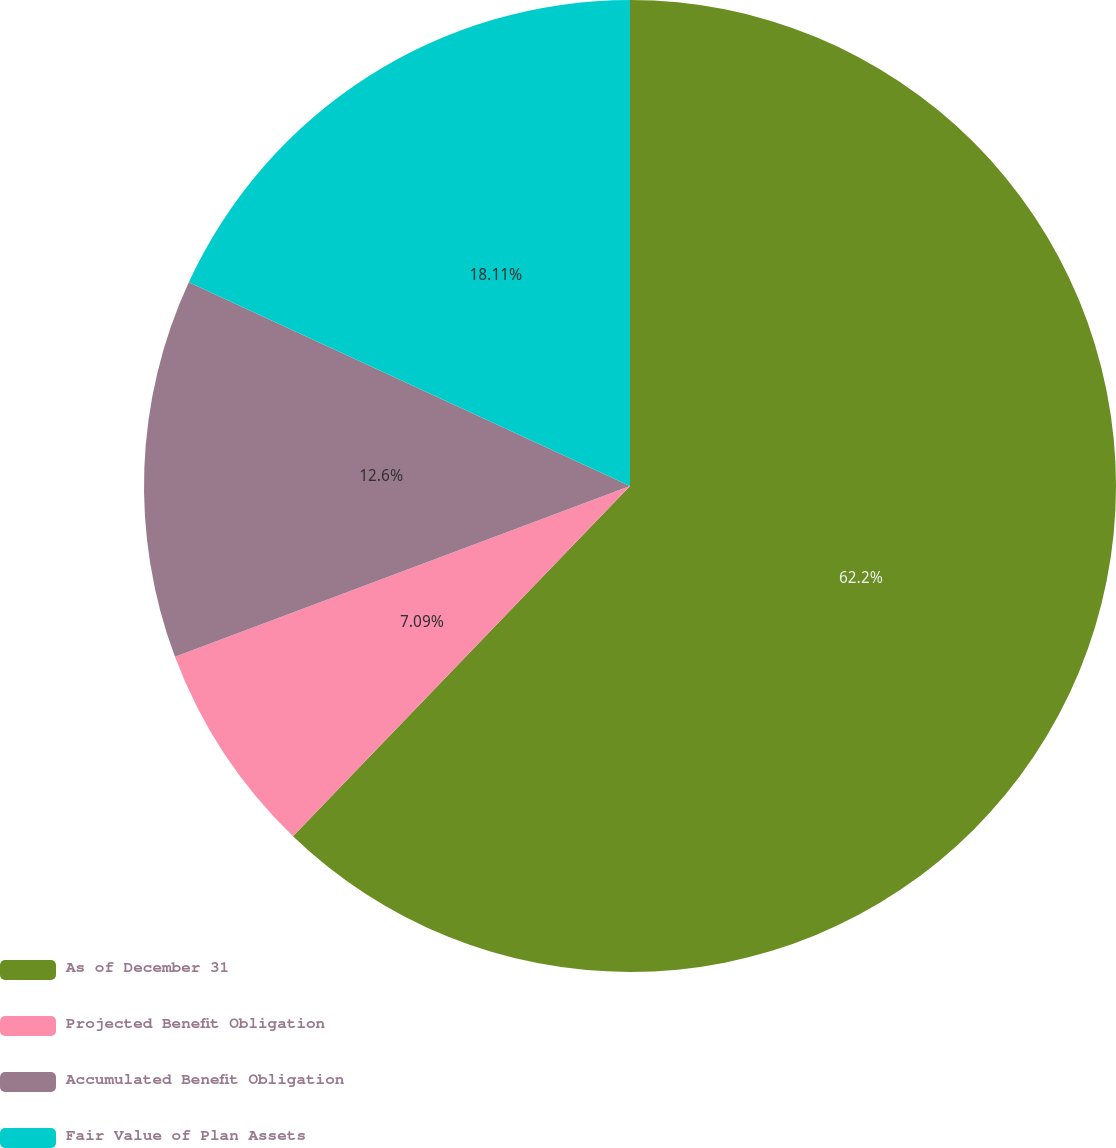<chart> <loc_0><loc_0><loc_500><loc_500><pie_chart><fcel>As of December 31<fcel>Projected Benefit Obligation<fcel>Accumulated Benefit Obligation<fcel>Fair Value of Plan Assets<nl><fcel>62.19%<fcel>7.09%<fcel>12.6%<fcel>18.11%<nl></chart> 